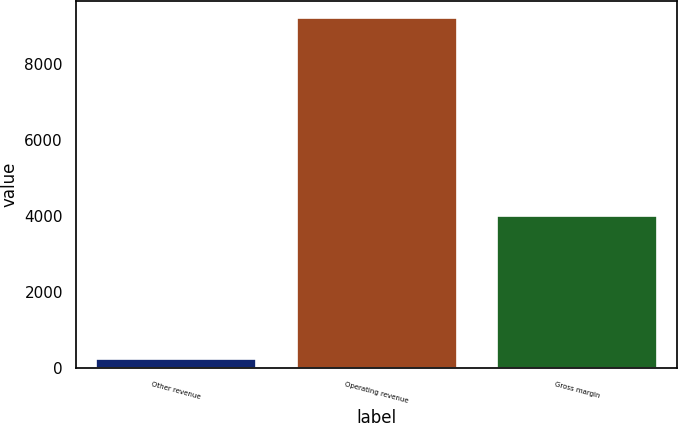Convert chart to OTSL. <chart><loc_0><loc_0><loc_500><loc_500><bar_chart><fcel>Other revenue<fcel>Operating revenue<fcel>Gross margin<nl><fcel>238<fcel>9202<fcel>3981<nl></chart> 